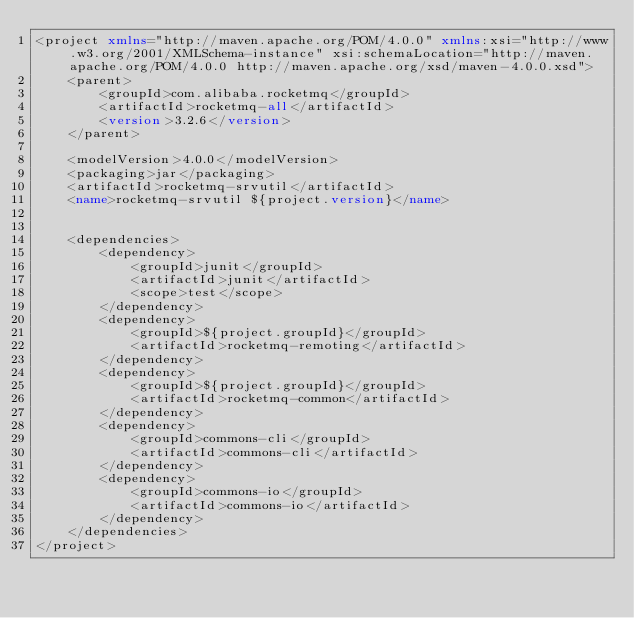Convert code to text. <code><loc_0><loc_0><loc_500><loc_500><_XML_><project xmlns="http://maven.apache.org/POM/4.0.0" xmlns:xsi="http://www.w3.org/2001/XMLSchema-instance" xsi:schemaLocation="http://maven.apache.org/POM/4.0.0 http://maven.apache.org/xsd/maven-4.0.0.xsd">
	<parent>
		<groupId>com.alibaba.rocketmq</groupId>
		<artifactId>rocketmq-all</artifactId>
		<version>3.2.6</version>
	</parent>

	<modelVersion>4.0.0</modelVersion>
	<packaging>jar</packaging>
	<artifactId>rocketmq-srvutil</artifactId>
	<name>rocketmq-srvutil ${project.version}</name>


	<dependencies>
		<dependency>
			<groupId>junit</groupId>
			<artifactId>junit</artifactId>
			<scope>test</scope>
		</dependency>
		<dependency>
			<groupId>${project.groupId}</groupId>
			<artifactId>rocketmq-remoting</artifactId>
		</dependency>
		<dependency>
			<groupId>${project.groupId}</groupId>
			<artifactId>rocketmq-common</artifactId>
		</dependency>
		<dependency>
			<groupId>commons-cli</groupId>
			<artifactId>commons-cli</artifactId>
		</dependency>
		<dependency>
			<groupId>commons-io</groupId>
			<artifactId>commons-io</artifactId>
		</dependency>
	</dependencies>
</project>
</code> 